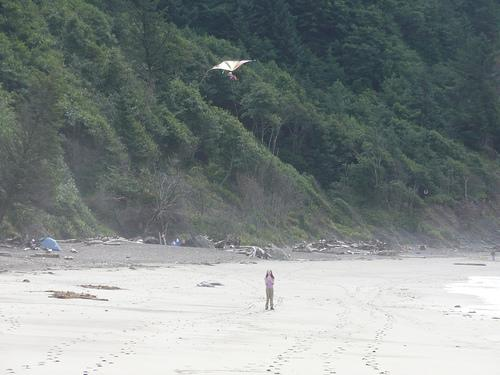What flutters just beneath the main body of this kite?

Choices:
A) nothing
B) eagle
C) tail
D) pigeon tail 